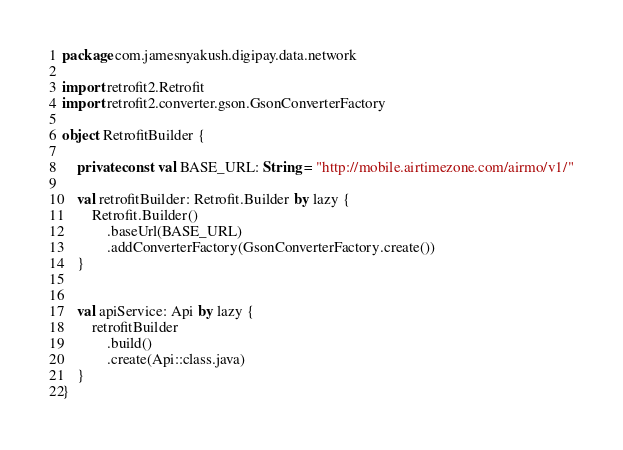<code> <loc_0><loc_0><loc_500><loc_500><_Kotlin_>package com.jamesnyakush.digipay.data.network

import retrofit2.Retrofit
import retrofit2.converter.gson.GsonConverterFactory

object RetrofitBuilder {

    private const val BASE_URL: String = "http://mobile.airtimezone.com/airmo/v1/"

    val retrofitBuilder: Retrofit.Builder by lazy {
        Retrofit.Builder()
            .baseUrl(BASE_URL)
            .addConverterFactory(GsonConverterFactory.create())
    }


    val apiService: Api by lazy {
        retrofitBuilder
            .build()
            .create(Api::class.java)
    }
}</code> 